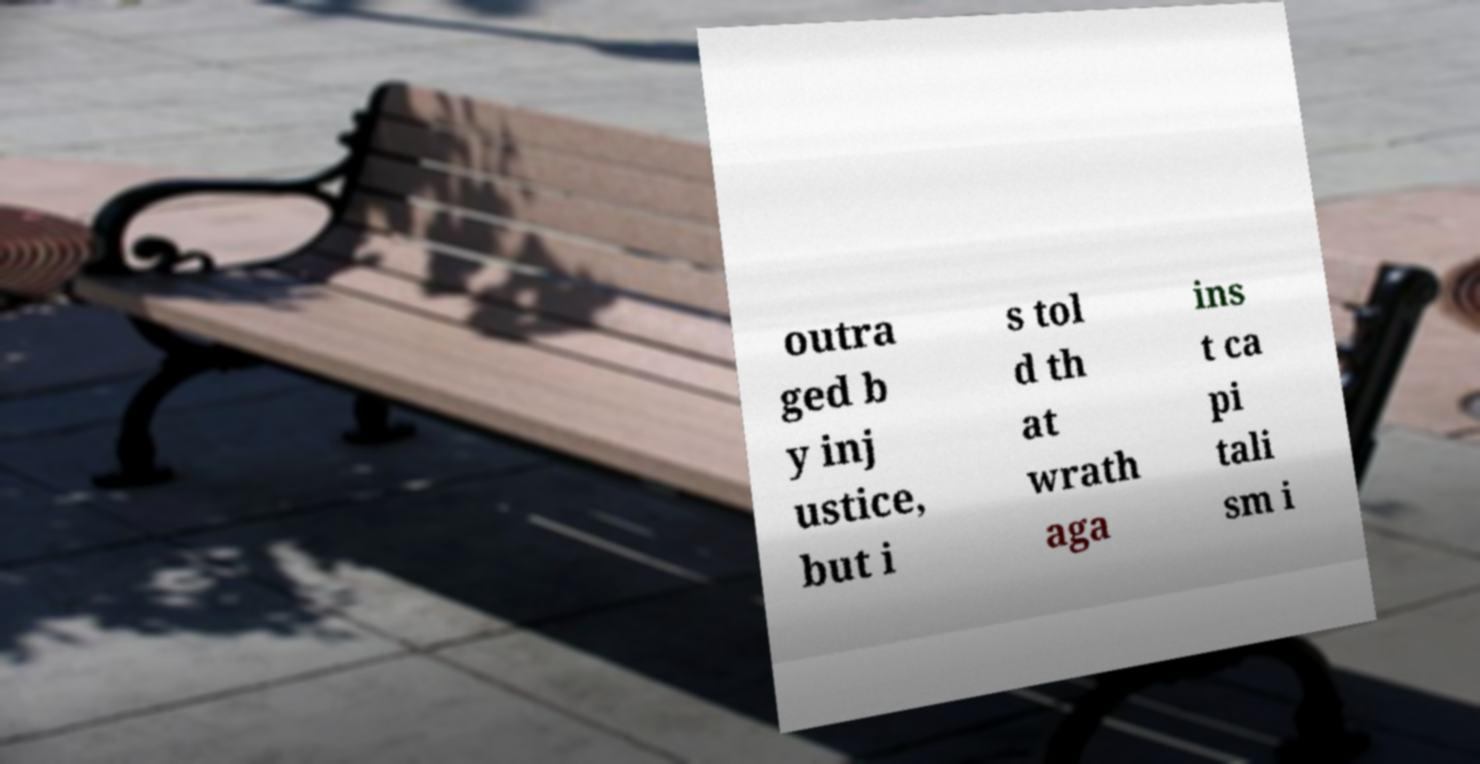I need the written content from this picture converted into text. Can you do that? outra ged b y inj ustice, but i s tol d th at wrath aga ins t ca pi tali sm i 